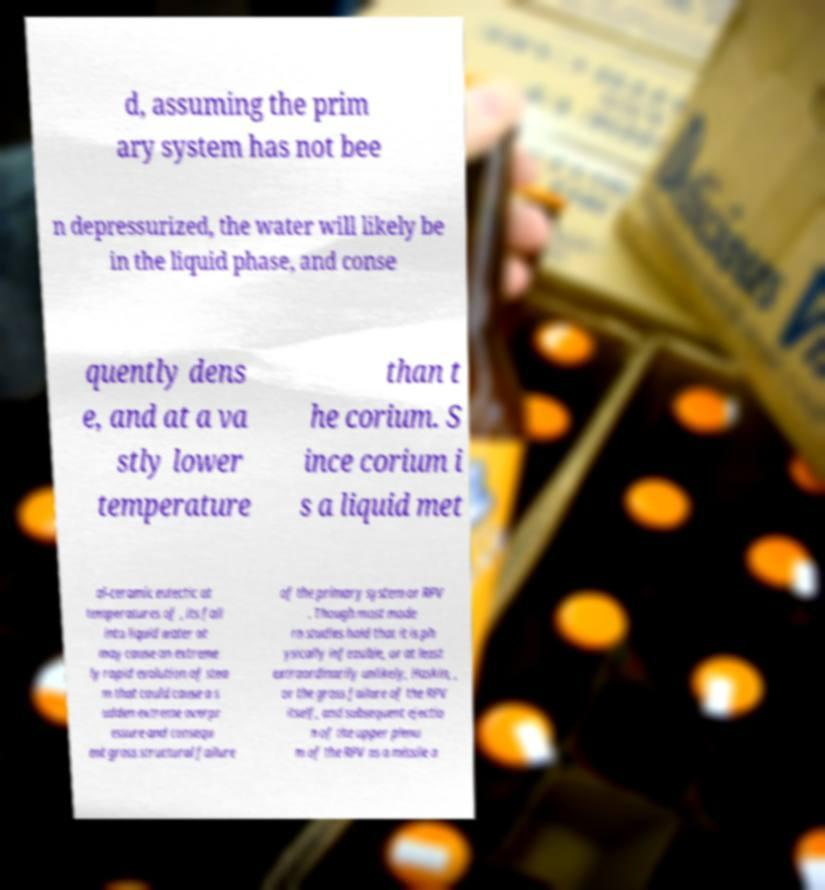Please identify and transcribe the text found in this image. d, assuming the prim ary system has not bee n depressurized, the water will likely be in the liquid phase, and conse quently dens e, and at a va stly lower temperature than t he corium. S ince corium i s a liquid met al-ceramic eutectic at temperatures of , its fall into liquid water at may cause an extreme ly rapid evolution of stea m that could cause a s udden extreme overpr essure and consequ ent gross structural failure of the primary system or RPV . Though most mode rn studies hold that it is ph ysically infeasible, or at least extraordinarily unlikely, Haskin, , or the gross failure of the RPV itself, and subsequent ejectio n of the upper plenu m of the RPV as a missile a 